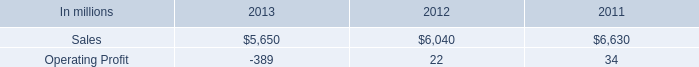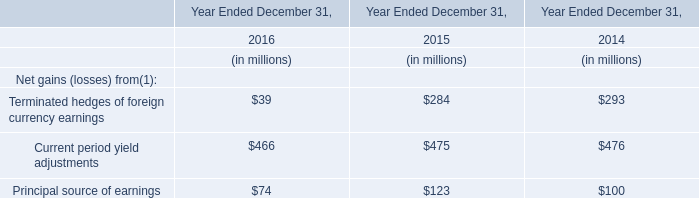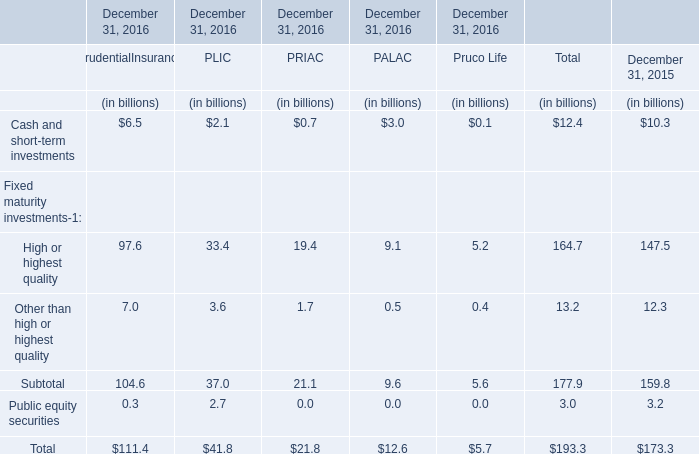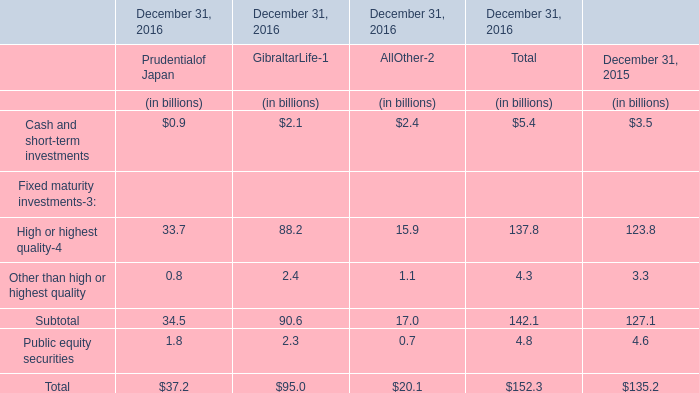What's the sum of all Other than high or highest quality that are positive in 2016? (in billion) 
Computations: ((0.8 + 2.4) + 1.1)
Answer: 4.3. 